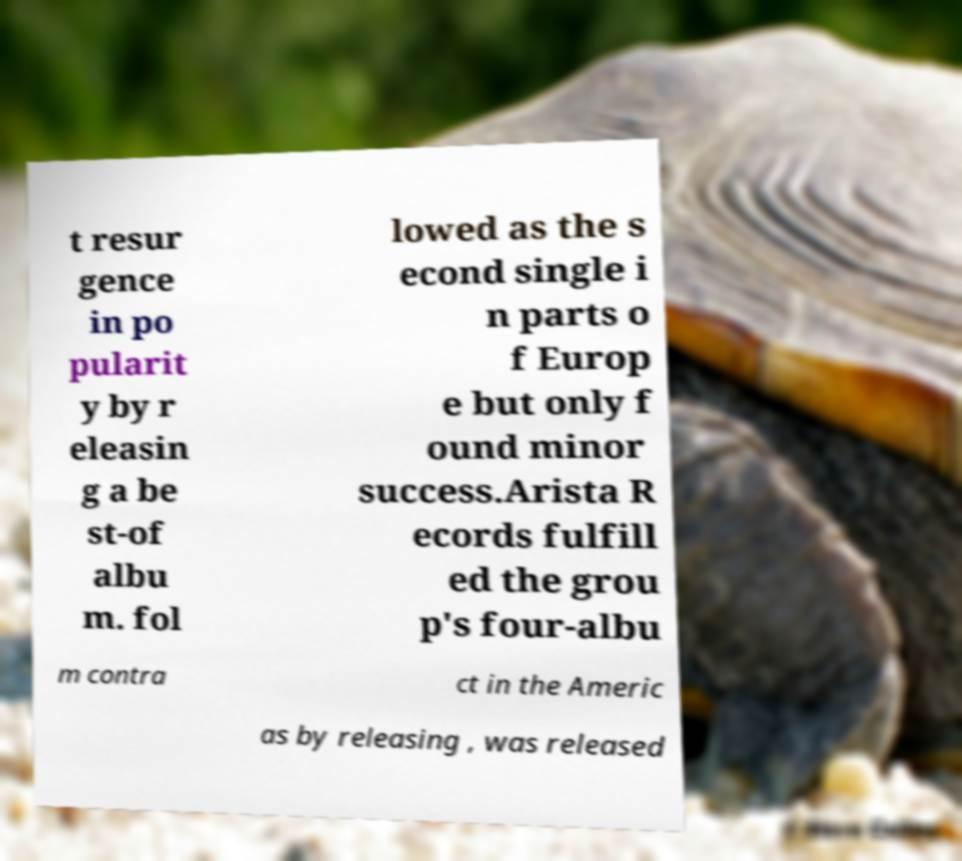Can you accurately transcribe the text from the provided image for me? t resur gence in po pularit y by r eleasin g a be st-of albu m. fol lowed as the s econd single i n parts o f Europ e but only f ound minor success.Arista R ecords fulfill ed the grou p's four-albu m contra ct in the Americ as by releasing , was released 